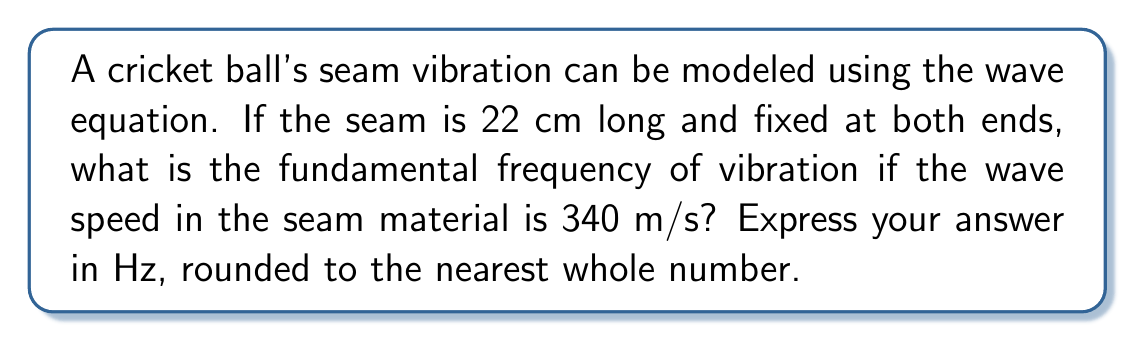Give your solution to this math problem. Let's approach this step-by-step using the wave equation:

1) The wave equation for a vibrating string (which we can use to model the seam) is:

   $$\frac{\partial^2 y}{\partial t^2} = v^2 \frac{\partial^2 y}{\partial x^2}$$

   where $v$ is the wave speed.

2) For a string fixed at both ends, the fundamental frequency is given by:

   $$f_1 = \frac{v}{2L}$$

   where $L$ is the length of the string.

3) We're given:
   - Length of the seam, $L = 22$ cm $= 0.22$ m
   - Wave speed, $v = 340$ m/s

4) Let's substitute these values into our equation:

   $$f_1 = \frac{340}{2(0.22)}$$

5) Simplifying:

   $$f_1 = \frac{340}{0.44} = 772.73$$ Hz

6) Rounding to the nearest whole number:

   $f_1 \approx 773$ Hz

This represents the fundamental frequency of vibration for the cricket ball's seam.
Answer: 773 Hz 